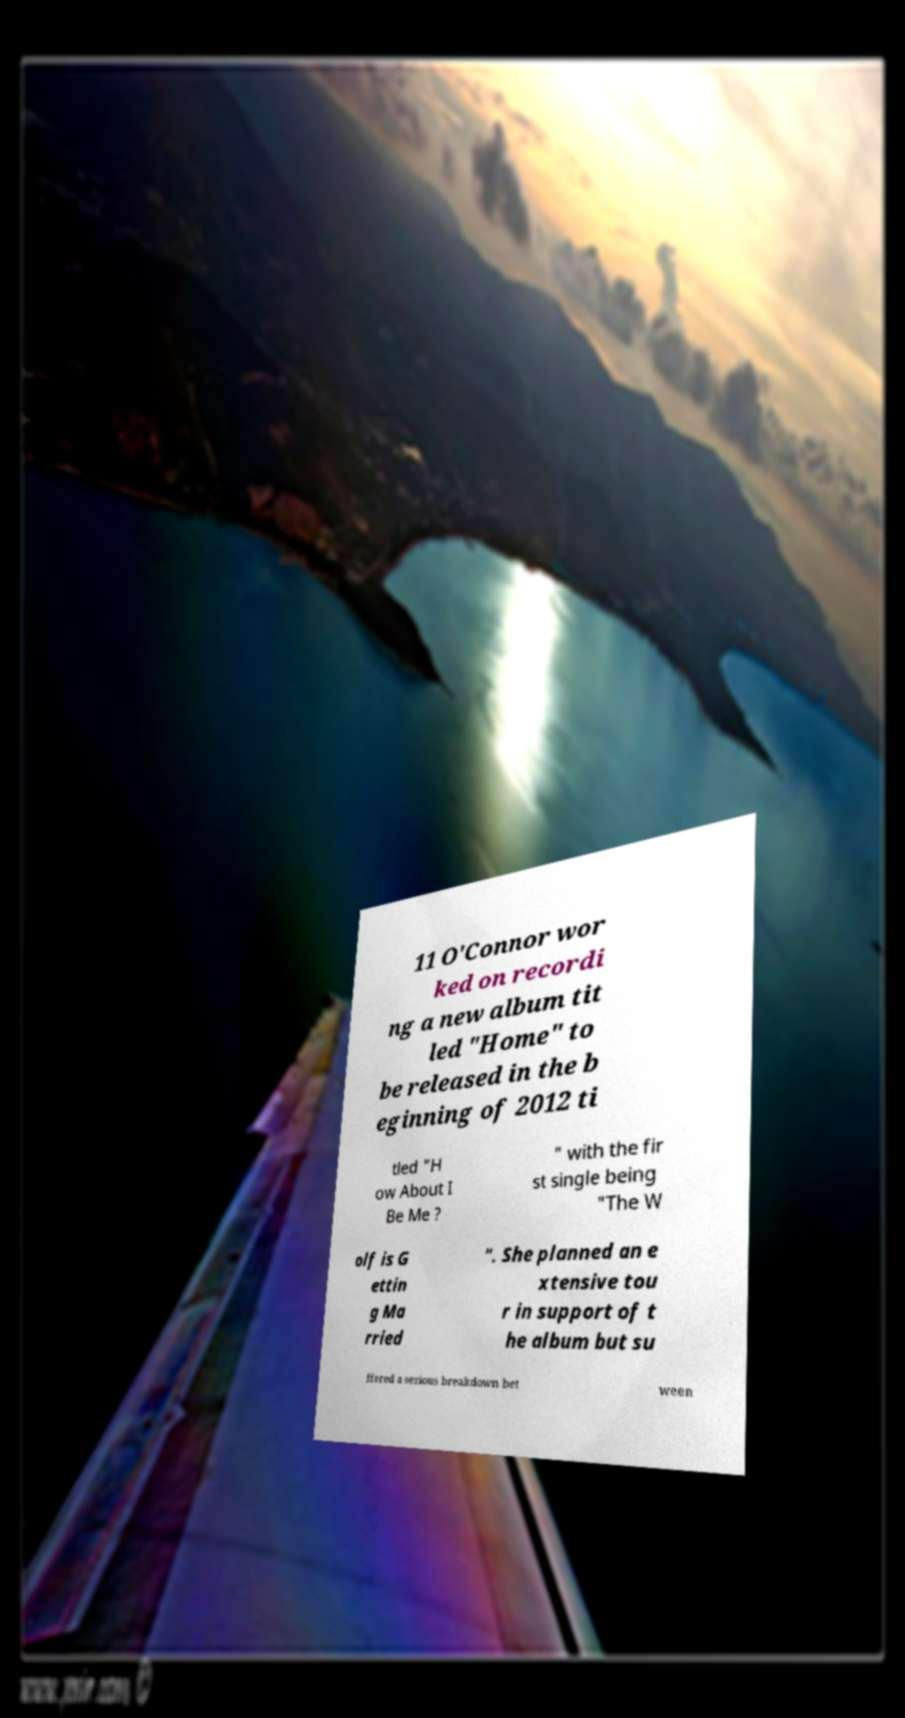There's text embedded in this image that I need extracted. Can you transcribe it verbatim? 11 O'Connor wor ked on recordi ng a new album tit led "Home" to be released in the b eginning of 2012 ti tled "H ow About I Be Me ? " with the fir st single being "The W olf is G ettin g Ma rried ". She planned an e xtensive tou r in support of t he album but su ffered a serious breakdown bet ween 